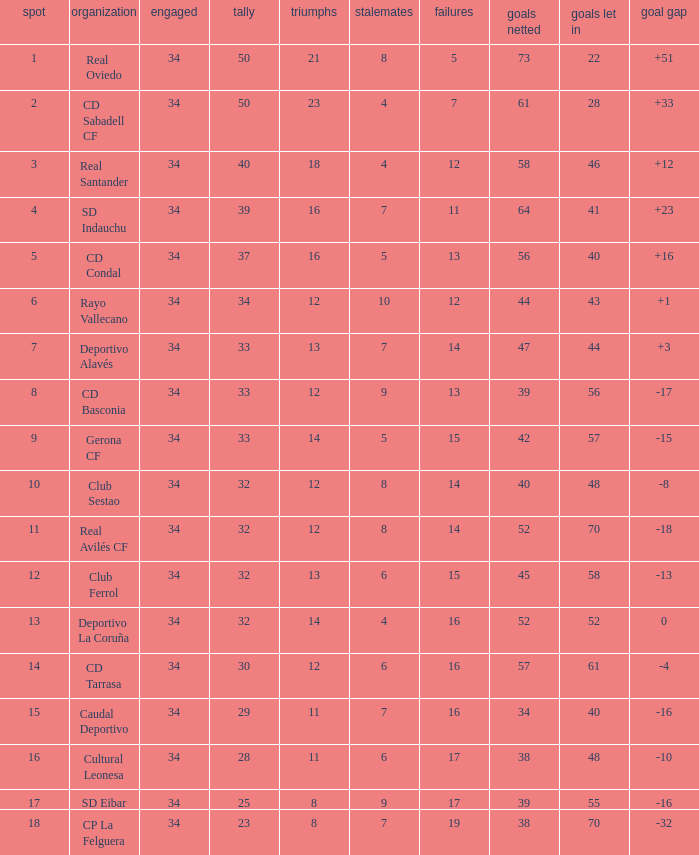Which Played has Draws smaller than 7, and Goals for smaller than 61, and Goals against smaller than 48, and a Position of 5? 34.0. 